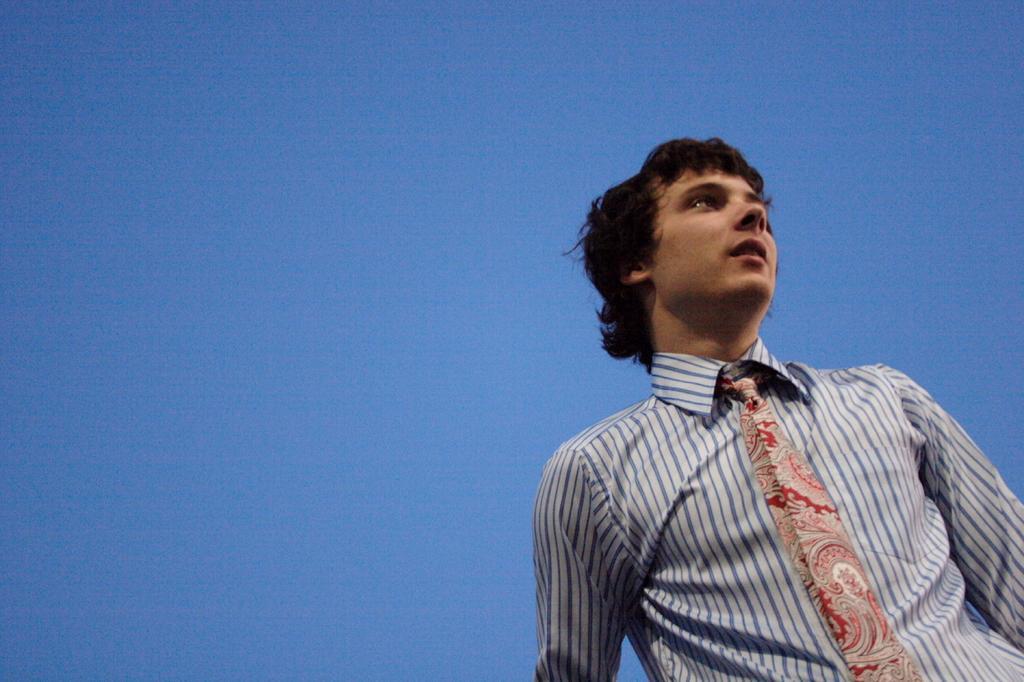In one or two sentences, can you explain what this image depicts? On the right side of the image we can see one person is standing. And he is wearing a tie and a blue and white color shirt. In the background we can see the sky. 